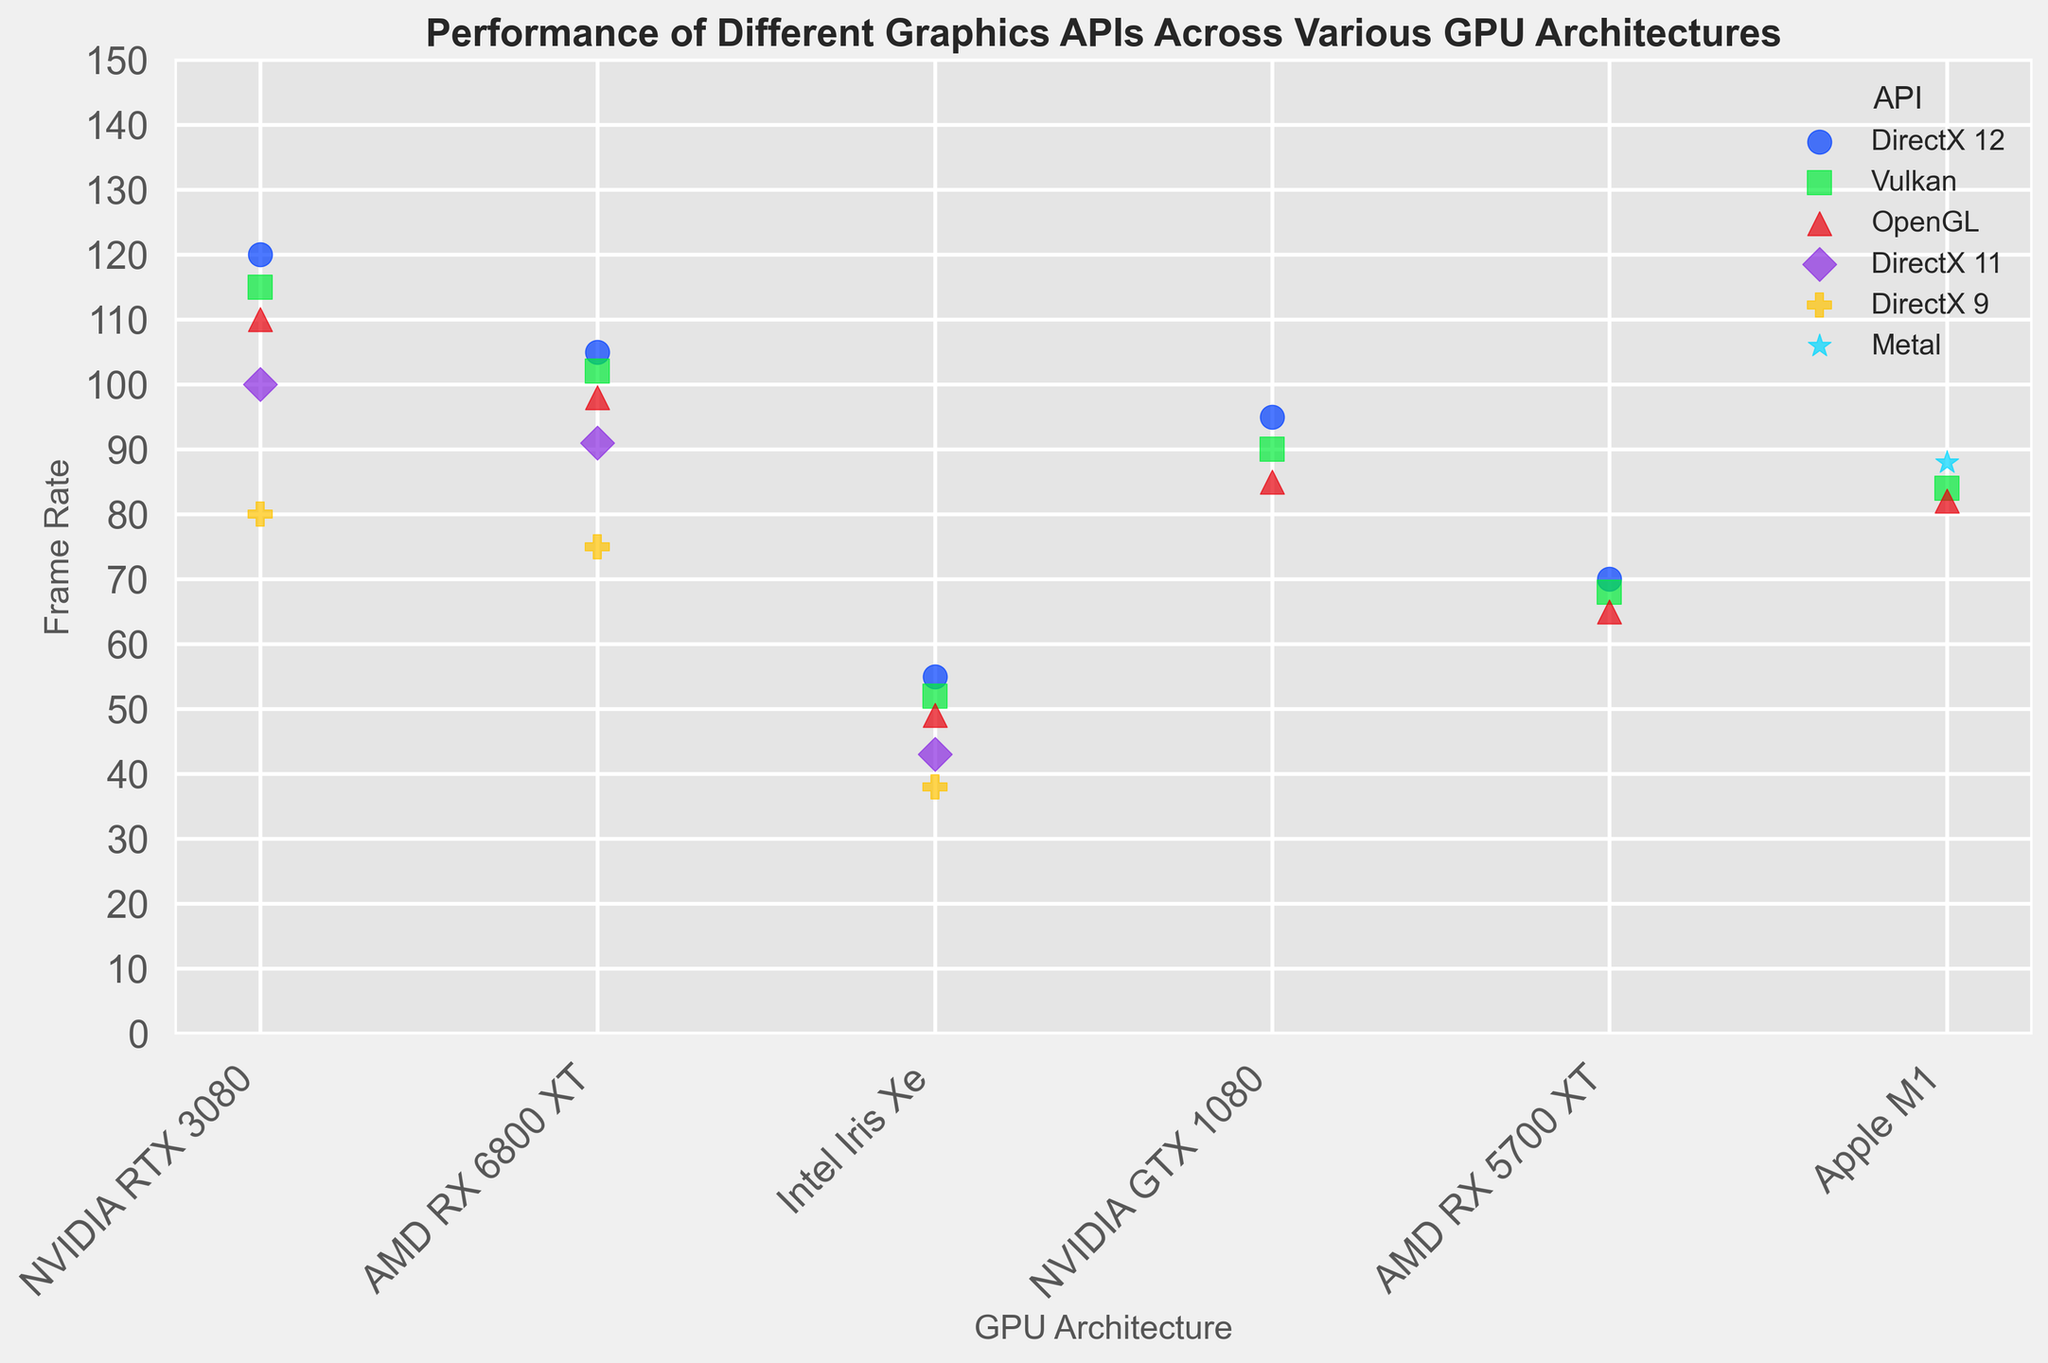Which API offers the highest frame rate across all GPU architectures? To determine the highest frame rate, examine each API's scatter points across the GPUs. DirectX 12 on the NVIDIA RTX 3080 reaches 120 FPS, which is the highest.
Answer: DirectX 12 How does the frame rate of OpenGL compare between NVIDIA RTX 3080 and Intel Iris Xe? For OpenGL, observe the frame rates on both GPUs. The NVIDIA RTX 3080 shows 110 FPS, while Intel Iris Xe shows 49 FPS. The frame rate on NVIDIA RTX 3080 is higher.
Answer: NVIDIA RTX 3080 has a higher frame rate What's the average frame rate for Vulkan across all GPU architectures? Sum the Vulkan frame rates across each GPU (115 + 102 + 52 + 84 + 90 + 68) = 511 and divide by the number of GPUs (6). 511/6 ≈ 85.2
Answer: 85.2 Among the GPUs with the DirectX 12 API, which GPU has the lowest frame rate? For DirectX 12, look at the frame rates across all GPUs. The Intel Iris Xe has the lowest frame rate at 55 FPS.
Answer: Intel Iris Xe Which API has the most consistent frame rate performance across different GPU architectures (least variation)? To determine consistency, look at the range in frame rates for each API. DirectX 11 varies from 100 to 43 FPS (57 FPS range). OpenGL varies from 110 to 49 FPS (61 FPS range). DirectX 12 varies from 120 to 55 FPS (65 FPS range). Vulkan varies from 115 to 52 FPS (63 FPS range). OpenGL is the most consistent.
Answer: OpenGL How much higher is the frame rate of DirectX 12 on AMD RX 6800 XT compared to OpenGL on the same GPU? Compare the frame rates of DirectX 12 (105 FPS) and OpenGL (98 FPS) on AMD RX 6800 XT. 105 - 98 = 7 FPS.
Answer: 7 FPS What is the frame rate difference between Metal on Apple M1 and Vulkan on NVIDIA GTX 1080? Compare the frame rate of Metal on Apple M1 (88 FPS) and Vulkan on NVIDIA GTX 1080 (90 FPS). 90 - 88 = 2 FPS.
Answer: 2 FPS Rank the GPUs in descending order of performance for the Vulkan API. Rank the frame rates for Vulkan: NVIDIA RTX 3080 (115 FPS), AMD RX 6800 XT (102 FPS), Apple M1 (84 FPS), NVIDIA GTX 1080 (90 FPS), AMD RX 5700 XT (68 FPS), Intel Iris Xe (52 FPS).
Answer: NVIDIA RTX 3080, NVIDIA GTX 1080, AMD RX 6800 XT, Apple M1, AMD RX 5700 XT, Intel Iris Xe What trends can be observed about the performance of OpenGL across different GPUs? Observing the plot, OpenGL tends to perform slightly below DirectX 12 and Vulkan across most GPUs, with a varying frame rate spanning from 110 FPS (NVIDIA RTX 3080) to 49 FPS (Intel Iris Xe).
Answer: OpenGL generally has lower performance compared to DirectX 12 and Vulkan across GPUs How do the performance levels of the APIs for the NVIDIA GTX 1080 compare with each other? For NVIDIA GTX 1080, compare frame rates: DirectX 12 (95 FPS), Vulkan (90 FPS), and OpenGL (85 FPS). DirectX 12 > Vulkan > OpenGL.
Answer: DirectX 12 > Vulkan > OpenGL 